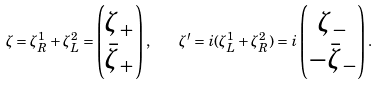<formula> <loc_0><loc_0><loc_500><loc_500>\zeta = \zeta ^ { 1 } _ { R } + \zeta ^ { 2 } _ { L } = \begin{pmatrix} \zeta _ { + } \\ \bar { \zeta } _ { + } \end{pmatrix} , \quad \zeta ^ { \prime } = i ( \zeta ^ { 1 } _ { L } + \zeta ^ { 2 } _ { R } ) = i \begin{pmatrix} \zeta _ { - } \\ - \bar { \zeta } _ { - } \end{pmatrix} .</formula> 